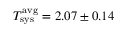Convert formula to latex. <formula><loc_0><loc_0><loc_500><loc_500>T _ { s y s } ^ { a v g } = 2 . 0 7 \pm 0 . 1 4</formula> 